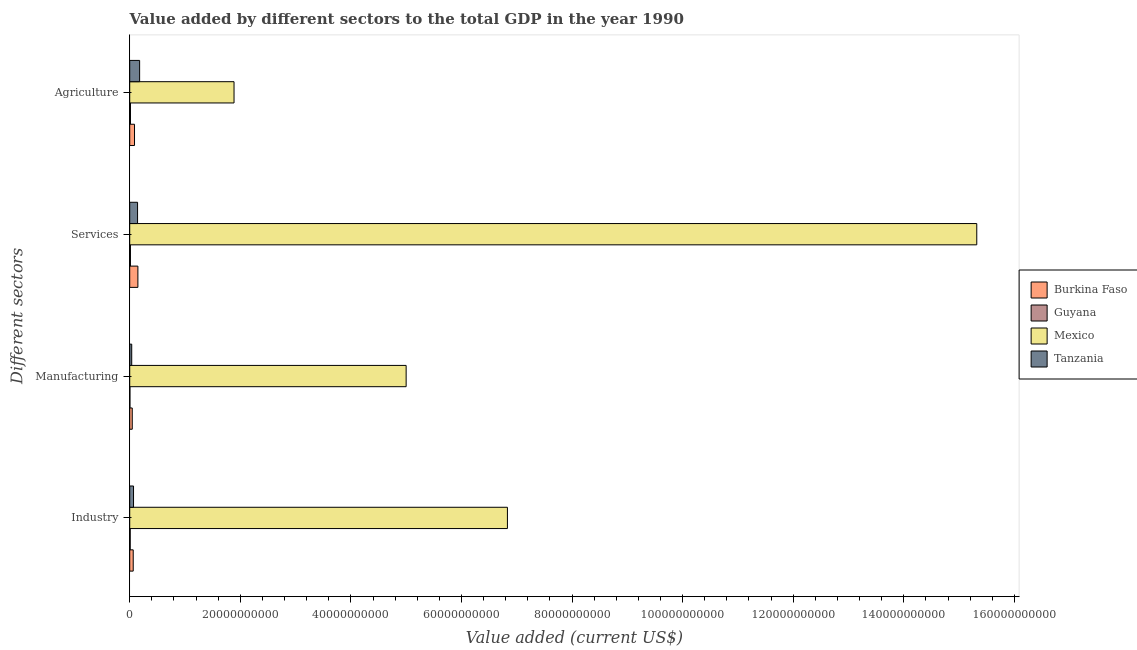Are the number of bars per tick equal to the number of legend labels?
Give a very brief answer. Yes. Are the number of bars on each tick of the Y-axis equal?
Your answer should be very brief. Yes. How many bars are there on the 4th tick from the top?
Keep it short and to the point. 4. What is the label of the 3rd group of bars from the top?
Provide a short and direct response. Manufacturing. What is the value added by industrial sector in Mexico?
Make the answer very short. 6.83e+1. Across all countries, what is the maximum value added by agricultural sector?
Your response must be concise. 1.89e+1. Across all countries, what is the minimum value added by agricultural sector?
Provide a short and direct response. 1.33e+08. In which country was the value added by agricultural sector minimum?
Your answer should be compact. Guyana. What is the total value added by agricultural sector in the graph?
Provide a short and direct response. 2.17e+1. What is the difference between the value added by manufacturing sector in Mexico and that in Tanzania?
Give a very brief answer. 4.96e+1. What is the difference between the value added by industrial sector in Burkina Faso and the value added by agricultural sector in Guyana?
Keep it short and to the point. 4.99e+08. What is the average value added by services sector per country?
Offer a terse response. 3.91e+1. What is the difference between the value added by manufacturing sector and value added by services sector in Guyana?
Give a very brief answer. -9.35e+07. In how many countries, is the value added by manufacturing sector greater than 96000000000 US$?
Offer a very short reply. 0. What is the ratio of the value added by manufacturing sector in Burkina Faso to that in Guyana?
Make the answer very short. 12.68. Is the value added by agricultural sector in Guyana less than that in Mexico?
Keep it short and to the point. Yes. Is the difference between the value added by industrial sector in Mexico and Tanzania greater than the difference between the value added by agricultural sector in Mexico and Tanzania?
Your answer should be very brief. Yes. What is the difference between the highest and the second highest value added by manufacturing sector?
Offer a terse response. 4.95e+1. What is the difference between the highest and the lowest value added by manufacturing sector?
Ensure brevity in your answer.  5.00e+1. In how many countries, is the value added by agricultural sector greater than the average value added by agricultural sector taken over all countries?
Provide a succinct answer. 1. Is the sum of the value added by services sector in Guyana and Tanzania greater than the maximum value added by industrial sector across all countries?
Your response must be concise. No. Is it the case that in every country, the sum of the value added by services sector and value added by agricultural sector is greater than the sum of value added by industrial sector and value added by manufacturing sector?
Ensure brevity in your answer.  No. What does the 1st bar from the top in Agriculture represents?
Keep it short and to the point. Tanzania. What does the 2nd bar from the bottom in Manufacturing represents?
Offer a terse response. Guyana. Is it the case that in every country, the sum of the value added by industrial sector and value added by manufacturing sector is greater than the value added by services sector?
Keep it short and to the point. No. How many bars are there?
Keep it short and to the point. 16. Are all the bars in the graph horizontal?
Provide a short and direct response. Yes. Are the values on the major ticks of X-axis written in scientific E-notation?
Offer a terse response. No. How many legend labels are there?
Provide a short and direct response. 4. How are the legend labels stacked?
Your answer should be very brief. Vertical. What is the title of the graph?
Provide a succinct answer. Value added by different sectors to the total GDP in the year 1990. Does "Zambia" appear as one of the legend labels in the graph?
Your answer should be compact. No. What is the label or title of the X-axis?
Offer a terse response. Value added (current US$). What is the label or title of the Y-axis?
Give a very brief answer. Different sectors. What is the Value added (current US$) in Burkina Faso in Industry?
Make the answer very short. 6.32e+08. What is the Value added (current US$) of Guyana in Industry?
Give a very brief answer. 8.70e+07. What is the Value added (current US$) of Mexico in Industry?
Your response must be concise. 6.83e+1. What is the Value added (current US$) in Tanzania in Industry?
Give a very brief answer. 6.88e+08. What is the Value added (current US$) of Burkina Faso in Manufacturing?
Give a very brief answer. 4.57e+08. What is the Value added (current US$) in Guyana in Manufacturing?
Offer a terse response. 3.61e+07. What is the Value added (current US$) in Mexico in Manufacturing?
Provide a succinct answer. 5.00e+1. What is the Value added (current US$) of Tanzania in Manufacturing?
Keep it short and to the point. 3.61e+08. What is the Value added (current US$) in Burkina Faso in Services?
Keep it short and to the point. 1.48e+09. What is the Value added (current US$) in Guyana in Services?
Give a very brief answer. 1.30e+08. What is the Value added (current US$) in Mexico in Services?
Your answer should be compact. 1.53e+11. What is the Value added (current US$) of Tanzania in Services?
Make the answer very short. 1.42e+09. What is the Value added (current US$) in Burkina Faso in Agriculture?
Ensure brevity in your answer.  8.67e+08. What is the Value added (current US$) in Guyana in Agriculture?
Give a very brief answer. 1.33e+08. What is the Value added (current US$) of Mexico in Agriculture?
Offer a terse response. 1.89e+1. What is the Value added (current US$) in Tanzania in Agriculture?
Ensure brevity in your answer.  1.79e+09. Across all Different sectors, what is the maximum Value added (current US$) in Burkina Faso?
Provide a short and direct response. 1.48e+09. Across all Different sectors, what is the maximum Value added (current US$) of Guyana?
Your response must be concise. 1.33e+08. Across all Different sectors, what is the maximum Value added (current US$) of Mexico?
Provide a short and direct response. 1.53e+11. Across all Different sectors, what is the maximum Value added (current US$) in Tanzania?
Keep it short and to the point. 1.79e+09. Across all Different sectors, what is the minimum Value added (current US$) in Burkina Faso?
Provide a short and direct response. 4.57e+08. Across all Different sectors, what is the minimum Value added (current US$) in Guyana?
Keep it short and to the point. 3.61e+07. Across all Different sectors, what is the minimum Value added (current US$) of Mexico?
Your response must be concise. 1.89e+1. Across all Different sectors, what is the minimum Value added (current US$) in Tanzania?
Offer a terse response. 3.61e+08. What is the total Value added (current US$) in Burkina Faso in the graph?
Give a very brief answer. 3.43e+09. What is the total Value added (current US$) of Guyana in the graph?
Provide a succinct answer. 3.86e+08. What is the total Value added (current US$) in Mexico in the graph?
Make the answer very short. 2.90e+11. What is the total Value added (current US$) of Tanzania in the graph?
Make the answer very short. 4.26e+09. What is the difference between the Value added (current US$) in Burkina Faso in Industry and that in Manufacturing?
Provide a succinct answer. 1.74e+08. What is the difference between the Value added (current US$) of Guyana in Industry and that in Manufacturing?
Your response must be concise. 5.09e+07. What is the difference between the Value added (current US$) of Mexico in Industry and that in Manufacturing?
Your response must be concise. 1.83e+1. What is the difference between the Value added (current US$) in Tanzania in Industry and that in Manufacturing?
Provide a succinct answer. 3.26e+08. What is the difference between the Value added (current US$) of Burkina Faso in Industry and that in Services?
Your answer should be very brief. -8.44e+08. What is the difference between the Value added (current US$) of Guyana in Industry and that in Services?
Keep it short and to the point. -4.25e+07. What is the difference between the Value added (current US$) of Mexico in Industry and that in Services?
Offer a terse response. -8.49e+1. What is the difference between the Value added (current US$) of Tanzania in Industry and that in Services?
Offer a terse response. -7.30e+08. What is the difference between the Value added (current US$) in Burkina Faso in Industry and that in Agriculture?
Make the answer very short. -2.35e+08. What is the difference between the Value added (current US$) of Guyana in Industry and that in Agriculture?
Give a very brief answer. -4.62e+07. What is the difference between the Value added (current US$) of Mexico in Industry and that in Agriculture?
Your response must be concise. 4.94e+1. What is the difference between the Value added (current US$) in Tanzania in Industry and that in Agriculture?
Offer a very short reply. -1.10e+09. What is the difference between the Value added (current US$) in Burkina Faso in Manufacturing and that in Services?
Offer a terse response. -1.02e+09. What is the difference between the Value added (current US$) of Guyana in Manufacturing and that in Services?
Your answer should be very brief. -9.35e+07. What is the difference between the Value added (current US$) of Mexico in Manufacturing and that in Services?
Offer a terse response. -1.03e+11. What is the difference between the Value added (current US$) in Tanzania in Manufacturing and that in Services?
Your answer should be very brief. -1.06e+09. What is the difference between the Value added (current US$) in Burkina Faso in Manufacturing and that in Agriculture?
Ensure brevity in your answer.  -4.09e+08. What is the difference between the Value added (current US$) of Guyana in Manufacturing and that in Agriculture?
Ensure brevity in your answer.  -9.71e+07. What is the difference between the Value added (current US$) in Mexico in Manufacturing and that in Agriculture?
Your response must be concise. 3.11e+1. What is the difference between the Value added (current US$) in Tanzania in Manufacturing and that in Agriculture?
Provide a succinct answer. -1.43e+09. What is the difference between the Value added (current US$) of Burkina Faso in Services and that in Agriculture?
Ensure brevity in your answer.  6.09e+08. What is the difference between the Value added (current US$) of Guyana in Services and that in Agriculture?
Offer a very short reply. -3.65e+06. What is the difference between the Value added (current US$) of Mexico in Services and that in Agriculture?
Provide a short and direct response. 1.34e+11. What is the difference between the Value added (current US$) in Tanzania in Services and that in Agriculture?
Ensure brevity in your answer.  -3.73e+08. What is the difference between the Value added (current US$) in Burkina Faso in Industry and the Value added (current US$) in Guyana in Manufacturing?
Offer a very short reply. 5.96e+08. What is the difference between the Value added (current US$) of Burkina Faso in Industry and the Value added (current US$) of Mexico in Manufacturing?
Ensure brevity in your answer.  -4.94e+1. What is the difference between the Value added (current US$) in Burkina Faso in Industry and the Value added (current US$) in Tanzania in Manufacturing?
Your response must be concise. 2.70e+08. What is the difference between the Value added (current US$) in Guyana in Industry and the Value added (current US$) in Mexico in Manufacturing?
Give a very brief answer. -4.99e+1. What is the difference between the Value added (current US$) of Guyana in Industry and the Value added (current US$) of Tanzania in Manufacturing?
Offer a very short reply. -2.74e+08. What is the difference between the Value added (current US$) of Mexico in Industry and the Value added (current US$) of Tanzania in Manufacturing?
Your answer should be compact. 6.79e+1. What is the difference between the Value added (current US$) in Burkina Faso in Industry and the Value added (current US$) in Guyana in Services?
Your answer should be very brief. 5.02e+08. What is the difference between the Value added (current US$) in Burkina Faso in Industry and the Value added (current US$) in Mexico in Services?
Your response must be concise. -1.53e+11. What is the difference between the Value added (current US$) in Burkina Faso in Industry and the Value added (current US$) in Tanzania in Services?
Your response must be concise. -7.86e+08. What is the difference between the Value added (current US$) of Guyana in Industry and the Value added (current US$) of Mexico in Services?
Provide a short and direct response. -1.53e+11. What is the difference between the Value added (current US$) of Guyana in Industry and the Value added (current US$) of Tanzania in Services?
Your response must be concise. -1.33e+09. What is the difference between the Value added (current US$) of Mexico in Industry and the Value added (current US$) of Tanzania in Services?
Your answer should be very brief. 6.69e+1. What is the difference between the Value added (current US$) in Burkina Faso in Industry and the Value added (current US$) in Guyana in Agriculture?
Keep it short and to the point. 4.99e+08. What is the difference between the Value added (current US$) of Burkina Faso in Industry and the Value added (current US$) of Mexico in Agriculture?
Offer a very short reply. -1.82e+1. What is the difference between the Value added (current US$) in Burkina Faso in Industry and the Value added (current US$) in Tanzania in Agriculture?
Keep it short and to the point. -1.16e+09. What is the difference between the Value added (current US$) in Guyana in Industry and the Value added (current US$) in Mexico in Agriculture?
Provide a short and direct response. -1.88e+1. What is the difference between the Value added (current US$) of Guyana in Industry and the Value added (current US$) of Tanzania in Agriculture?
Ensure brevity in your answer.  -1.70e+09. What is the difference between the Value added (current US$) in Mexico in Industry and the Value added (current US$) in Tanzania in Agriculture?
Offer a very short reply. 6.65e+1. What is the difference between the Value added (current US$) of Burkina Faso in Manufacturing and the Value added (current US$) of Guyana in Services?
Keep it short and to the point. 3.28e+08. What is the difference between the Value added (current US$) in Burkina Faso in Manufacturing and the Value added (current US$) in Mexico in Services?
Your response must be concise. -1.53e+11. What is the difference between the Value added (current US$) in Burkina Faso in Manufacturing and the Value added (current US$) in Tanzania in Services?
Ensure brevity in your answer.  -9.61e+08. What is the difference between the Value added (current US$) in Guyana in Manufacturing and the Value added (current US$) in Mexico in Services?
Your response must be concise. -1.53e+11. What is the difference between the Value added (current US$) in Guyana in Manufacturing and the Value added (current US$) in Tanzania in Services?
Offer a terse response. -1.38e+09. What is the difference between the Value added (current US$) in Mexico in Manufacturing and the Value added (current US$) in Tanzania in Services?
Your answer should be compact. 4.86e+1. What is the difference between the Value added (current US$) in Burkina Faso in Manufacturing and the Value added (current US$) in Guyana in Agriculture?
Provide a short and direct response. 3.24e+08. What is the difference between the Value added (current US$) of Burkina Faso in Manufacturing and the Value added (current US$) of Mexico in Agriculture?
Ensure brevity in your answer.  -1.84e+1. What is the difference between the Value added (current US$) in Burkina Faso in Manufacturing and the Value added (current US$) in Tanzania in Agriculture?
Keep it short and to the point. -1.33e+09. What is the difference between the Value added (current US$) in Guyana in Manufacturing and the Value added (current US$) in Mexico in Agriculture?
Your answer should be very brief. -1.88e+1. What is the difference between the Value added (current US$) of Guyana in Manufacturing and the Value added (current US$) of Tanzania in Agriculture?
Make the answer very short. -1.75e+09. What is the difference between the Value added (current US$) of Mexico in Manufacturing and the Value added (current US$) of Tanzania in Agriculture?
Provide a succinct answer. 4.82e+1. What is the difference between the Value added (current US$) in Burkina Faso in Services and the Value added (current US$) in Guyana in Agriculture?
Ensure brevity in your answer.  1.34e+09. What is the difference between the Value added (current US$) in Burkina Faso in Services and the Value added (current US$) in Mexico in Agriculture?
Keep it short and to the point. -1.74e+1. What is the difference between the Value added (current US$) of Burkina Faso in Services and the Value added (current US$) of Tanzania in Agriculture?
Offer a terse response. -3.15e+08. What is the difference between the Value added (current US$) in Guyana in Services and the Value added (current US$) in Mexico in Agriculture?
Provide a succinct answer. -1.87e+1. What is the difference between the Value added (current US$) in Guyana in Services and the Value added (current US$) in Tanzania in Agriculture?
Make the answer very short. -1.66e+09. What is the difference between the Value added (current US$) of Mexico in Services and the Value added (current US$) of Tanzania in Agriculture?
Ensure brevity in your answer.  1.51e+11. What is the average Value added (current US$) of Burkina Faso per Different sectors?
Your response must be concise. 8.58e+08. What is the average Value added (current US$) in Guyana per Different sectors?
Provide a short and direct response. 9.65e+07. What is the average Value added (current US$) in Mexico per Different sectors?
Make the answer very short. 7.26e+1. What is the average Value added (current US$) in Tanzania per Different sectors?
Give a very brief answer. 1.06e+09. What is the difference between the Value added (current US$) of Burkina Faso and Value added (current US$) of Guyana in Industry?
Give a very brief answer. 5.45e+08. What is the difference between the Value added (current US$) of Burkina Faso and Value added (current US$) of Mexico in Industry?
Make the answer very short. -6.77e+1. What is the difference between the Value added (current US$) of Burkina Faso and Value added (current US$) of Tanzania in Industry?
Keep it short and to the point. -5.60e+07. What is the difference between the Value added (current US$) in Guyana and Value added (current US$) in Mexico in Industry?
Make the answer very short. -6.82e+1. What is the difference between the Value added (current US$) of Guyana and Value added (current US$) of Tanzania in Industry?
Give a very brief answer. -6.01e+08. What is the difference between the Value added (current US$) in Mexico and Value added (current US$) in Tanzania in Industry?
Your answer should be compact. 6.76e+1. What is the difference between the Value added (current US$) in Burkina Faso and Value added (current US$) in Guyana in Manufacturing?
Provide a succinct answer. 4.21e+08. What is the difference between the Value added (current US$) in Burkina Faso and Value added (current US$) in Mexico in Manufacturing?
Keep it short and to the point. -4.95e+1. What is the difference between the Value added (current US$) in Burkina Faso and Value added (current US$) in Tanzania in Manufacturing?
Your response must be concise. 9.61e+07. What is the difference between the Value added (current US$) of Guyana and Value added (current US$) of Mexico in Manufacturing?
Provide a short and direct response. -5.00e+1. What is the difference between the Value added (current US$) in Guyana and Value added (current US$) in Tanzania in Manufacturing?
Give a very brief answer. -3.25e+08. What is the difference between the Value added (current US$) of Mexico and Value added (current US$) of Tanzania in Manufacturing?
Your response must be concise. 4.96e+1. What is the difference between the Value added (current US$) of Burkina Faso and Value added (current US$) of Guyana in Services?
Give a very brief answer. 1.35e+09. What is the difference between the Value added (current US$) in Burkina Faso and Value added (current US$) in Mexico in Services?
Your answer should be compact. -1.52e+11. What is the difference between the Value added (current US$) in Burkina Faso and Value added (current US$) in Tanzania in Services?
Your response must be concise. 5.80e+07. What is the difference between the Value added (current US$) of Guyana and Value added (current US$) of Mexico in Services?
Offer a very short reply. -1.53e+11. What is the difference between the Value added (current US$) in Guyana and Value added (current US$) in Tanzania in Services?
Your answer should be compact. -1.29e+09. What is the difference between the Value added (current US$) of Mexico and Value added (current US$) of Tanzania in Services?
Provide a short and direct response. 1.52e+11. What is the difference between the Value added (current US$) in Burkina Faso and Value added (current US$) in Guyana in Agriculture?
Your answer should be compact. 7.34e+08. What is the difference between the Value added (current US$) in Burkina Faso and Value added (current US$) in Mexico in Agriculture?
Your response must be concise. -1.80e+1. What is the difference between the Value added (current US$) in Burkina Faso and Value added (current US$) in Tanzania in Agriculture?
Your answer should be very brief. -9.24e+08. What is the difference between the Value added (current US$) in Guyana and Value added (current US$) in Mexico in Agriculture?
Your answer should be compact. -1.87e+1. What is the difference between the Value added (current US$) in Guyana and Value added (current US$) in Tanzania in Agriculture?
Offer a very short reply. -1.66e+09. What is the difference between the Value added (current US$) of Mexico and Value added (current US$) of Tanzania in Agriculture?
Keep it short and to the point. 1.71e+1. What is the ratio of the Value added (current US$) of Burkina Faso in Industry to that in Manufacturing?
Your response must be concise. 1.38. What is the ratio of the Value added (current US$) of Guyana in Industry to that in Manufacturing?
Offer a very short reply. 2.41. What is the ratio of the Value added (current US$) of Mexico in Industry to that in Manufacturing?
Offer a terse response. 1.37. What is the ratio of the Value added (current US$) of Tanzania in Industry to that in Manufacturing?
Your answer should be very brief. 1.9. What is the ratio of the Value added (current US$) in Burkina Faso in Industry to that in Services?
Make the answer very short. 0.43. What is the ratio of the Value added (current US$) in Guyana in Industry to that in Services?
Offer a very short reply. 0.67. What is the ratio of the Value added (current US$) of Mexico in Industry to that in Services?
Provide a short and direct response. 0.45. What is the ratio of the Value added (current US$) in Tanzania in Industry to that in Services?
Make the answer very short. 0.48. What is the ratio of the Value added (current US$) in Burkina Faso in Industry to that in Agriculture?
Give a very brief answer. 0.73. What is the ratio of the Value added (current US$) of Guyana in Industry to that in Agriculture?
Ensure brevity in your answer.  0.65. What is the ratio of the Value added (current US$) in Mexico in Industry to that in Agriculture?
Your response must be concise. 3.62. What is the ratio of the Value added (current US$) in Tanzania in Industry to that in Agriculture?
Give a very brief answer. 0.38. What is the ratio of the Value added (current US$) of Burkina Faso in Manufacturing to that in Services?
Ensure brevity in your answer.  0.31. What is the ratio of the Value added (current US$) in Guyana in Manufacturing to that in Services?
Provide a succinct answer. 0.28. What is the ratio of the Value added (current US$) of Mexico in Manufacturing to that in Services?
Provide a short and direct response. 0.33. What is the ratio of the Value added (current US$) in Tanzania in Manufacturing to that in Services?
Offer a very short reply. 0.25. What is the ratio of the Value added (current US$) in Burkina Faso in Manufacturing to that in Agriculture?
Your answer should be compact. 0.53. What is the ratio of the Value added (current US$) in Guyana in Manufacturing to that in Agriculture?
Your answer should be very brief. 0.27. What is the ratio of the Value added (current US$) of Mexico in Manufacturing to that in Agriculture?
Your answer should be compact. 2.65. What is the ratio of the Value added (current US$) in Tanzania in Manufacturing to that in Agriculture?
Your response must be concise. 0.2. What is the ratio of the Value added (current US$) in Burkina Faso in Services to that in Agriculture?
Your answer should be compact. 1.7. What is the ratio of the Value added (current US$) of Guyana in Services to that in Agriculture?
Make the answer very short. 0.97. What is the ratio of the Value added (current US$) in Mexico in Services to that in Agriculture?
Provide a short and direct response. 8.12. What is the ratio of the Value added (current US$) of Tanzania in Services to that in Agriculture?
Offer a very short reply. 0.79. What is the difference between the highest and the second highest Value added (current US$) in Burkina Faso?
Make the answer very short. 6.09e+08. What is the difference between the highest and the second highest Value added (current US$) in Guyana?
Offer a very short reply. 3.65e+06. What is the difference between the highest and the second highest Value added (current US$) in Mexico?
Your answer should be compact. 8.49e+1. What is the difference between the highest and the second highest Value added (current US$) in Tanzania?
Give a very brief answer. 3.73e+08. What is the difference between the highest and the lowest Value added (current US$) of Burkina Faso?
Give a very brief answer. 1.02e+09. What is the difference between the highest and the lowest Value added (current US$) of Guyana?
Provide a succinct answer. 9.71e+07. What is the difference between the highest and the lowest Value added (current US$) of Mexico?
Give a very brief answer. 1.34e+11. What is the difference between the highest and the lowest Value added (current US$) in Tanzania?
Your answer should be very brief. 1.43e+09. 